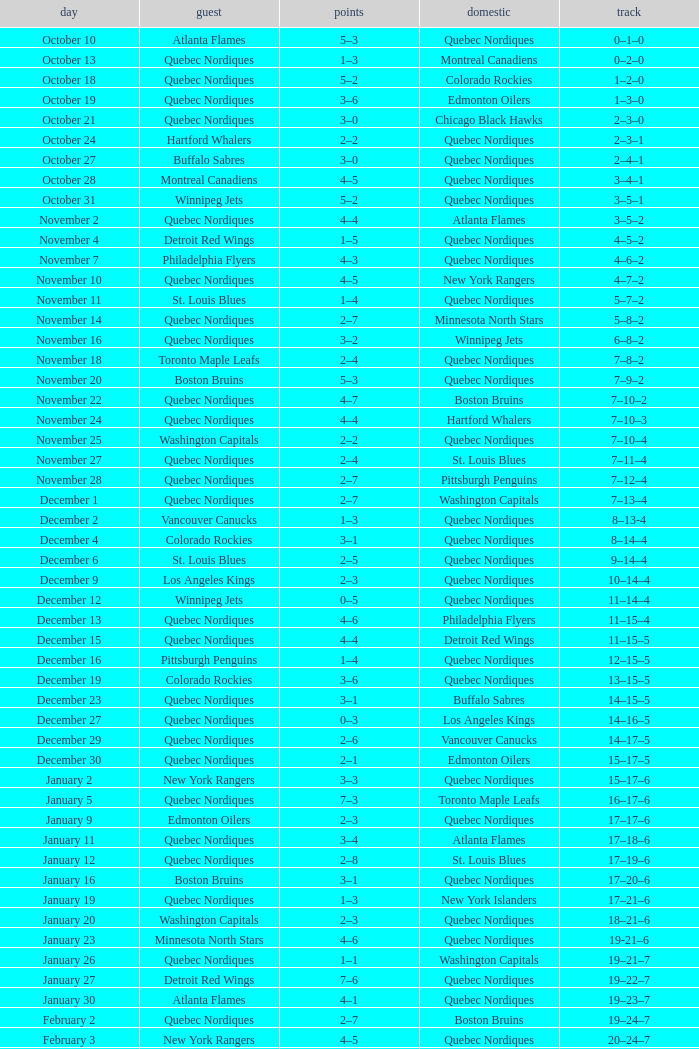Which Date has a Score of 2–7, and a Record of 5–8–2? November 14. 